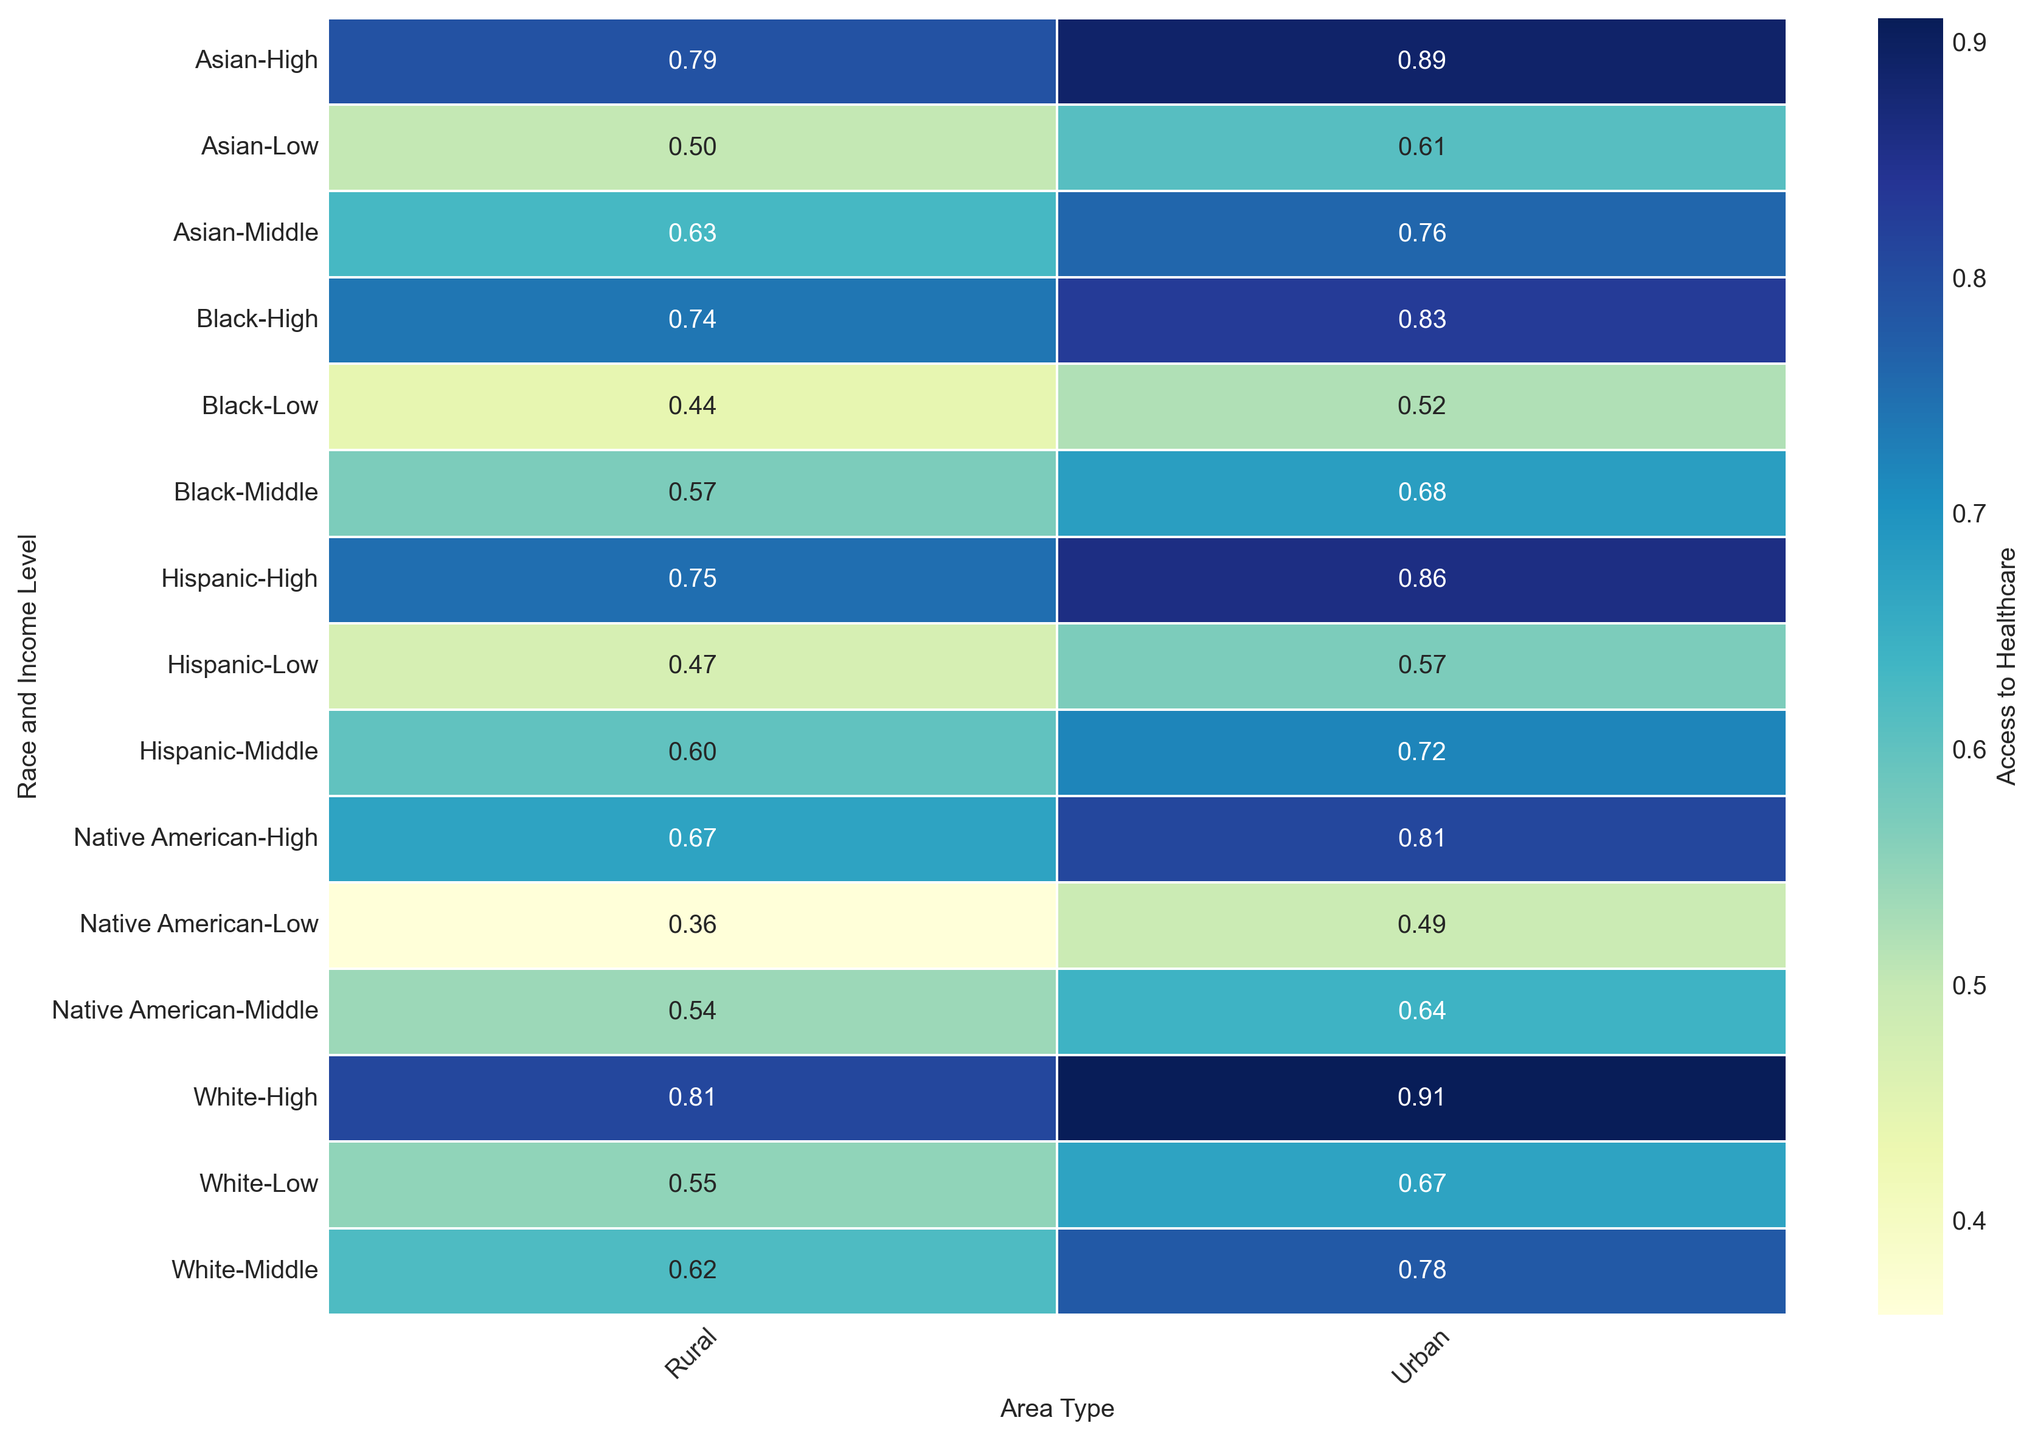Which race has the highest access to healthcare in high-income rural areas? Look for the highest value in the "High" income level and "Rural" area type cells. Identify the race associated with this cell.
Answer: White How does access to healthcare for Black individuals in urban areas compare between low and high-income levels? Compare the access values for Black individuals in urban areas across different income levels. Access is 0.52 for low-income and 0.83 for high-income. Deduct 0.52 from 0.83.
Answer: It improves by 0.31 What is the average access to healthcare for all races in rural areas with middle income? Look at the access values for all races categorized as "Middle" income in rural areas: 0.62 (White), 0.57 (Black), 0.60 (Hispanic), 0.63 (Asian), 0.54 (Native American). Calculate the average: (0.62 + 0.57 + 0.60 + 0.63 + 0.54) / 5
Answer: 0.59 Which group shows the most considerable difference in access to healthcare between urban and rural areas with low income? Compare the access values for low-income groups across urban and rural settings: 
White: 0.67-0.55 = 0.12 
Black: 0.52-0.44 = 0.08 
Hispanic: 0.57-0.47 = 0.10 
Asian: 0.61-0.50 = 0.11 
Native American: 0.49-0.36 = 0.13. 
Identify the maximum difference.
Answer: Native American For Hispanic individuals, which income level shows the smallest difference in access between urban and rural areas? Check the Hispanic access values for each income level and compare the differences between urban and rural.
Low: 0.57-0.47 = 0.10
Middle: 0.72-0.60 = 0.12
High: 0.86-0.75 = 0.11
Identify the smallest difference.
Answer: Low income What's the combined access to healthcare score for Asian and Native American individuals in high-income urban areas? Look at the access values for both groups in the "High" income level and urban areas:
Asian: 0.89
Native American: 0.81
Add both values: 0.89 + 0.81
Answer: 1.70 How does access to healthcare for low-income Asian individuals in urban areas compare to low-income White individuals in rural areas? Look at the access values for both groups:
Asian low-income urban: 0.61
White low-income rural: 0.55
Subtract the rural value from the urban value: 0.61 - 0.55
Answer: 0.06 more Which area type has a more significant variation in access to healthcare among different races for high-income individuals? Compare the range of access values for high-income individuals between urban and rural areas.
Urban values: White (0.91), Black (0.83), Hispanic (0.86), Asian (0.89), Native American (0.81) - Range: 0.91 - 0.81 = 0.10.
Rural values: White (0.81), Black (0.74), Hispanic (0.75), Asian (0.79), Native American (0.67) - Range: 0.81 - 0.67 = 0.14.
The larger range indicates more significant variation.
Answer: Rural areas 